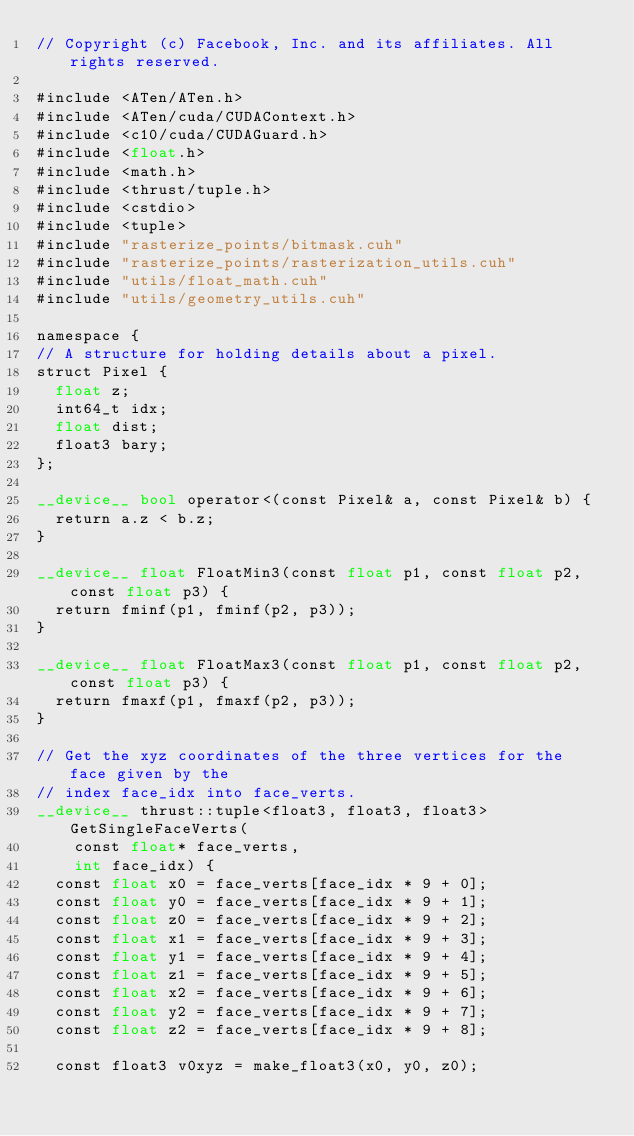<code> <loc_0><loc_0><loc_500><loc_500><_Cuda_>// Copyright (c) Facebook, Inc. and its affiliates. All rights reserved.

#include <ATen/ATen.h>
#include <ATen/cuda/CUDAContext.h>
#include <c10/cuda/CUDAGuard.h>
#include <float.h>
#include <math.h>
#include <thrust/tuple.h>
#include <cstdio>
#include <tuple>
#include "rasterize_points/bitmask.cuh"
#include "rasterize_points/rasterization_utils.cuh"
#include "utils/float_math.cuh"
#include "utils/geometry_utils.cuh"

namespace {
// A structure for holding details about a pixel.
struct Pixel {
  float z;
  int64_t idx;
  float dist;
  float3 bary;
};

__device__ bool operator<(const Pixel& a, const Pixel& b) {
  return a.z < b.z;
}

__device__ float FloatMin3(const float p1, const float p2, const float p3) {
  return fminf(p1, fminf(p2, p3));
}

__device__ float FloatMax3(const float p1, const float p2, const float p3) {
  return fmaxf(p1, fmaxf(p2, p3));
}

// Get the xyz coordinates of the three vertices for the face given by the
// index face_idx into face_verts.
__device__ thrust::tuple<float3, float3, float3> GetSingleFaceVerts(
    const float* face_verts,
    int face_idx) {
  const float x0 = face_verts[face_idx * 9 + 0];
  const float y0 = face_verts[face_idx * 9 + 1];
  const float z0 = face_verts[face_idx * 9 + 2];
  const float x1 = face_verts[face_idx * 9 + 3];
  const float y1 = face_verts[face_idx * 9 + 4];
  const float z1 = face_verts[face_idx * 9 + 5];
  const float x2 = face_verts[face_idx * 9 + 6];
  const float y2 = face_verts[face_idx * 9 + 7];
  const float z2 = face_verts[face_idx * 9 + 8];

  const float3 v0xyz = make_float3(x0, y0, z0);</code> 